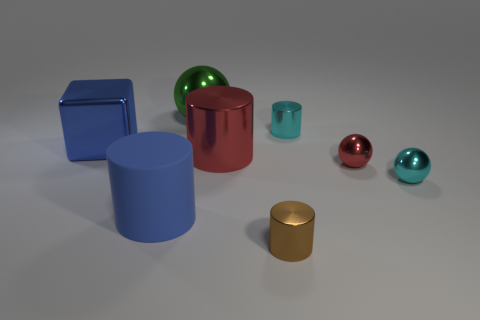Subtract all blue matte cylinders. How many cylinders are left? 3 Subtract 1 blocks. How many blocks are left? 0 Subtract all green spheres. How many spheres are left? 2 Add 2 purple matte cubes. How many objects exist? 10 Subtract all spheres. How many objects are left? 5 Subtract all gray balls. Subtract all gray cylinders. How many balls are left? 3 Subtract all brown cylinders. How many gray cubes are left? 0 Subtract all green shiny cubes. Subtract all tiny brown metallic things. How many objects are left? 7 Add 4 blue cylinders. How many blue cylinders are left? 5 Add 5 brown metal things. How many brown metal things exist? 6 